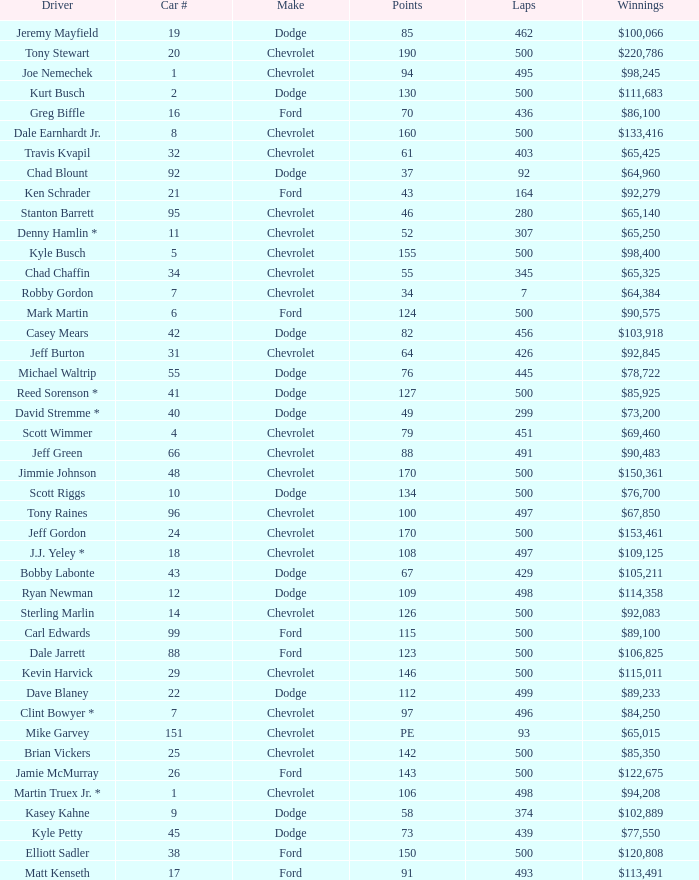Can you give me this table as a dict? {'header': ['Driver', 'Car #', 'Make', 'Points', 'Laps', 'Winnings'], 'rows': [['Jeremy Mayfield', '19', 'Dodge', '85', '462', '$100,066'], ['Tony Stewart', '20', 'Chevrolet', '190', '500', '$220,786'], ['Joe Nemechek', '1', 'Chevrolet', '94', '495', '$98,245'], ['Kurt Busch', '2', 'Dodge', '130', '500', '$111,683'], ['Greg Biffle', '16', 'Ford', '70', '436', '$86,100'], ['Dale Earnhardt Jr.', '8', 'Chevrolet', '160', '500', '$133,416'], ['Travis Kvapil', '32', 'Chevrolet', '61', '403', '$65,425'], ['Chad Blount', '92', 'Dodge', '37', '92', '$64,960'], ['Ken Schrader', '21', 'Ford', '43', '164', '$92,279'], ['Stanton Barrett', '95', 'Chevrolet', '46', '280', '$65,140'], ['Denny Hamlin *', '11', 'Chevrolet', '52', '307', '$65,250'], ['Kyle Busch', '5', 'Chevrolet', '155', '500', '$98,400'], ['Chad Chaffin', '34', 'Chevrolet', '55', '345', '$65,325'], ['Robby Gordon', '7', 'Chevrolet', '34', '7', '$64,384'], ['Mark Martin', '6', 'Ford', '124', '500', '$90,575'], ['Casey Mears', '42', 'Dodge', '82', '456', '$103,918'], ['Jeff Burton', '31', 'Chevrolet', '64', '426', '$92,845'], ['Michael Waltrip', '55', 'Dodge', '76', '445', '$78,722'], ['Reed Sorenson *', '41', 'Dodge', '127', '500', '$85,925'], ['David Stremme *', '40', 'Dodge', '49', '299', '$73,200'], ['Scott Wimmer', '4', 'Chevrolet', '79', '451', '$69,460'], ['Jeff Green', '66', 'Chevrolet', '88', '491', '$90,483'], ['Jimmie Johnson', '48', 'Chevrolet', '170', '500', '$150,361'], ['Scott Riggs', '10', 'Dodge', '134', '500', '$76,700'], ['Tony Raines', '96', 'Chevrolet', '100', '497', '$67,850'], ['Jeff Gordon', '24', 'Chevrolet', '170', '500', '$153,461'], ['J.J. Yeley *', '18', 'Chevrolet', '108', '497', '$109,125'], ['Bobby Labonte', '43', 'Dodge', '67', '429', '$105,211'], ['Ryan Newman', '12', 'Dodge', '109', '498', '$114,358'], ['Sterling Marlin', '14', 'Chevrolet', '126', '500', '$92,083'], ['Carl Edwards', '99', 'Ford', '115', '500', '$89,100'], ['Dale Jarrett', '88', 'Ford', '123', '500', '$106,825'], ['Kevin Harvick', '29', 'Chevrolet', '146', '500', '$115,011'], ['Dave Blaney', '22', 'Dodge', '112', '499', '$89,233'], ['Clint Bowyer *', '7', 'Chevrolet', '97', '496', '$84,250'], ['Mike Garvey', '151', 'Chevrolet', 'PE', '93', '$65,015'], ['Brian Vickers', '25', 'Chevrolet', '142', '500', '$85,350'], ['Jamie McMurray', '26', 'Ford', '143', '500', '$122,675'], ['Martin Truex Jr. *', '1', 'Chevrolet', '106', '498', '$94,208'], ['Kasey Kahne', '9', 'Dodge', '58', '374', '$102,889'], ['Kyle Petty', '45', 'Dodge', '73', '439', '$77,550'], ['Elliott Sadler', '38', 'Ford', '150', '500', '$120,808'], ['Matt Kenseth', '17', 'Ford', '91', '493', '$113,491']]} What is the average car number of all the drivers who have won $111,683? 2.0. 